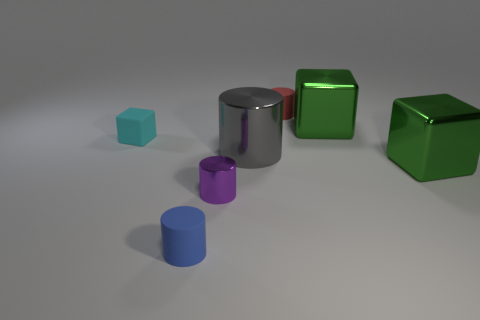Add 2 blue matte cylinders. How many objects exist? 9 Subtract all cylinders. How many objects are left? 3 Add 3 green metallic objects. How many green metallic objects are left? 5 Add 4 big blue shiny balls. How many big blue shiny balls exist? 4 Subtract 1 purple cylinders. How many objects are left? 6 Subtract all blue rubber things. Subtract all green cubes. How many objects are left? 4 